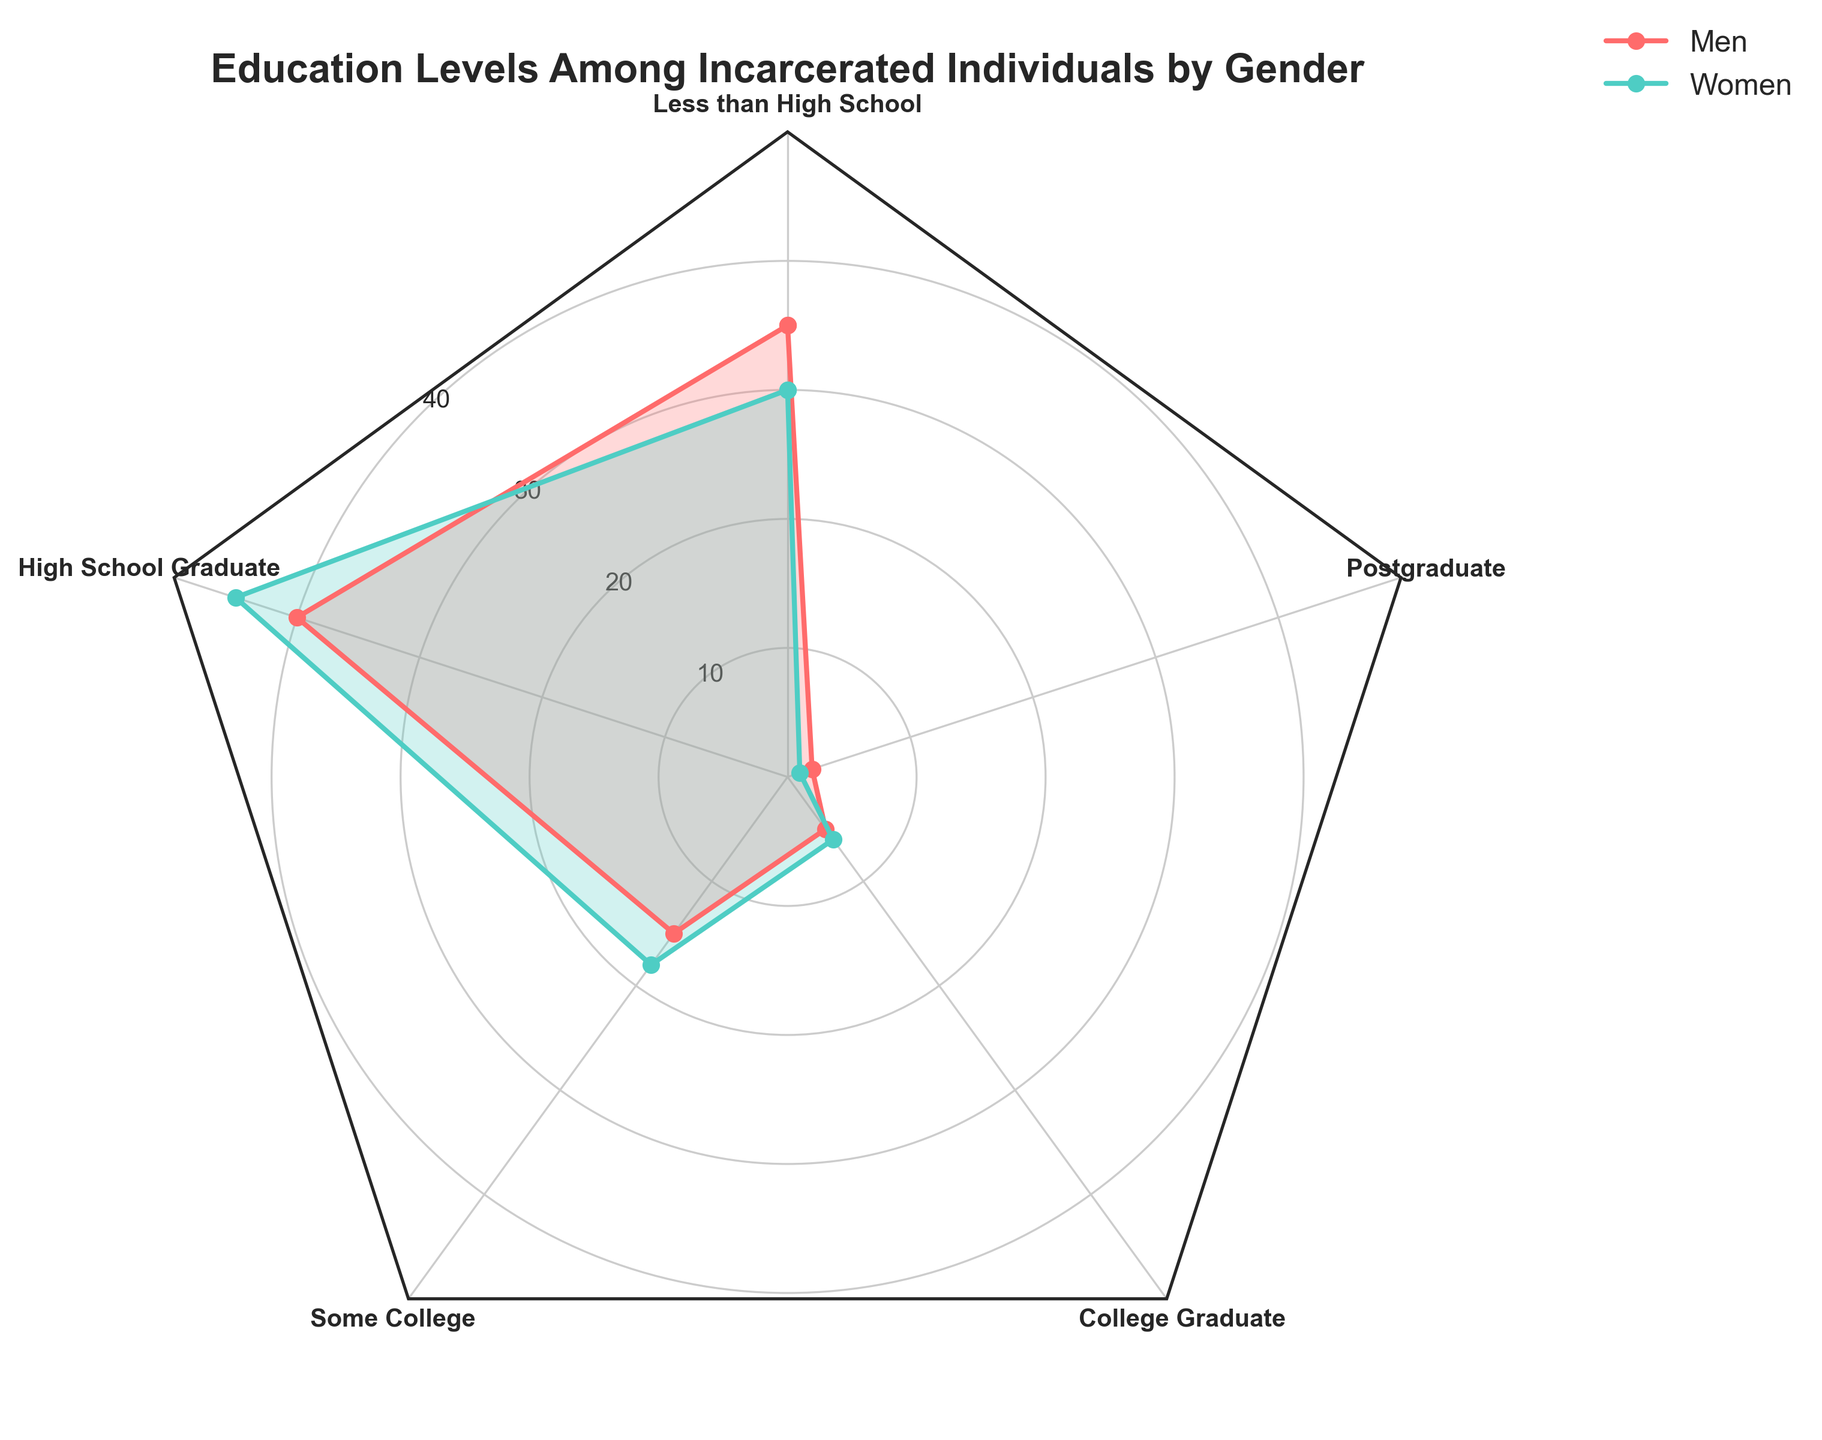What's the title of the figure? The title is usually given at the top of the figure. Here, it states the figure's topic and scope.
Answer: Education Levels Among Incarcerated Individuals by Gender What education level has the highest percentage for men? Observe the radar chart and find the education level corresponding to the longest spoke for men.
Answer: High School Graduate Which gender has a higher percentage of high school graduates? Compare the radar chart values for men and women at the "High School Graduate" point.
Answer: Women Which education level shows the largest discrepancy between men and women? Find the education level with the largest gap between the two lines representing men and women.
Answer: Less than High School What is the difference in percentage between men and women with a college graduate education level? Calculate the percentage for men and women at "College Graduate" and subtract one from the other.
Answer: 1% How many education levels show a higher percentage for women than men? Count the number of times the women's line extends further from the center than the men's line at different education levels.
Answer: 2 What is the average percentage of incarcerated women who are high school graduates and have some college education? Add the percentages for "High School Graduate" and "Some College" for women, then divide by 2.
Answer: 31.5% What is the total percentage of men with education levels lower than college? Sum the percentages for men in "Less than High School," "High School Graduate," and "Some College."
Answer: 90% What trend can be observed in the percentages for postgraduate education between men and women? Look at the radar chart values for "Postgraduate" education and compare them.
Answer: Both percentages are very low, with men slightly higher Which gender has a more even distribution across the different education levels? Assess the radar chart and see which gender's percentages are closer together across different education levels.
Answer: Women 